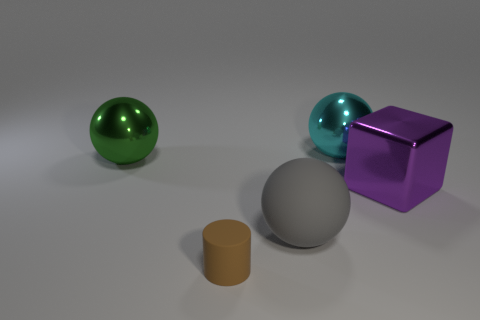Add 1 matte things. How many objects exist? 6 Subtract all big cyan metal spheres. How many spheres are left? 2 Subtract 1 spheres. How many spheres are left? 2 Subtract all blocks. How many objects are left? 4 Subtract all big red shiny objects. Subtract all gray balls. How many objects are left? 4 Add 5 tiny cylinders. How many tiny cylinders are left? 6 Add 4 cyan shiny spheres. How many cyan shiny spheres exist? 5 Subtract 1 purple cubes. How many objects are left? 4 Subtract all red spheres. Subtract all red cylinders. How many spheres are left? 3 